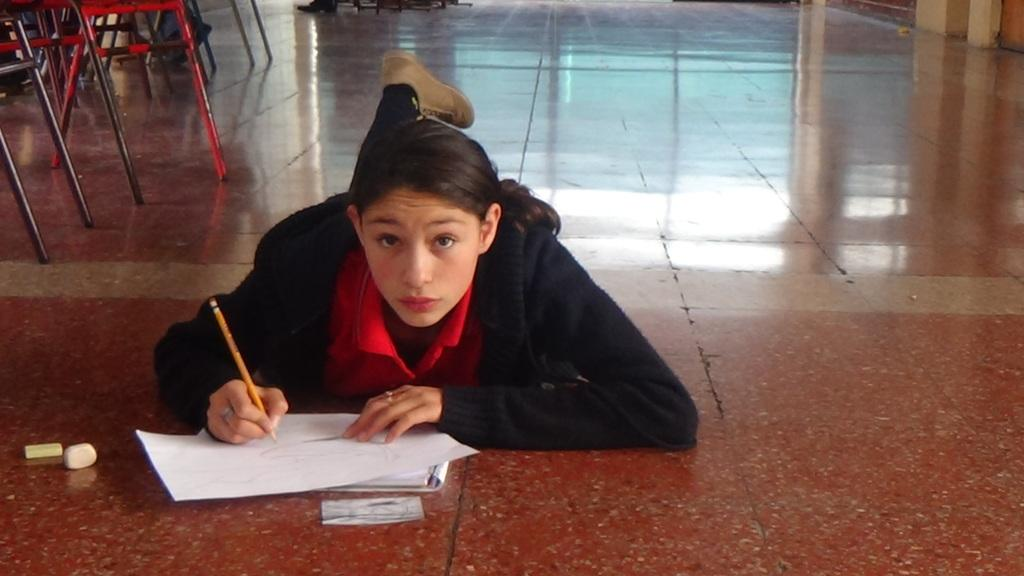Who is present in the image? There is a woman in the image. What is the woman doing in the image? The woman is lying on the floor and writing. What object is the woman holding in the image? The woman is holding a pen in the image. What items are present in the image that might be used for correcting mistakes? There are erasers in the image. What furniture can be seen at the top of the image? There are chairs visible at the top of the image. What type of nest can be seen in the image? There is no nest present in the image; it features a woman lying on the floor and writing. What type of circle is the woman drawing in the image? There is no indication in the image that the woman is drawing a circle or any specific shape. 